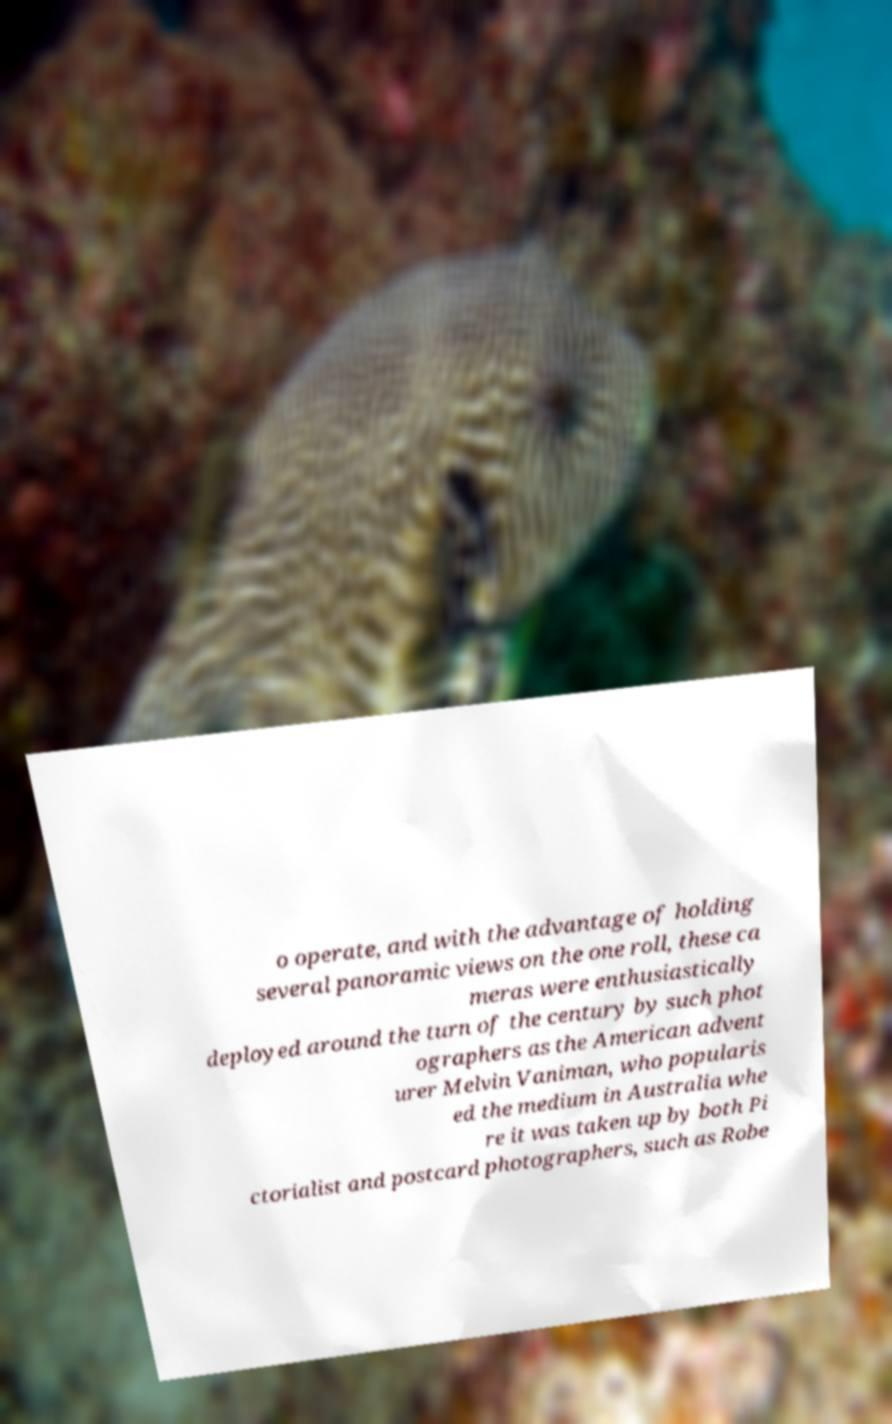Can you read and provide the text displayed in the image?This photo seems to have some interesting text. Can you extract and type it out for me? o operate, and with the advantage of holding several panoramic views on the one roll, these ca meras were enthusiastically deployed around the turn of the century by such phot ographers as the American advent urer Melvin Vaniman, who popularis ed the medium in Australia whe re it was taken up by both Pi ctorialist and postcard photographers, such as Robe 